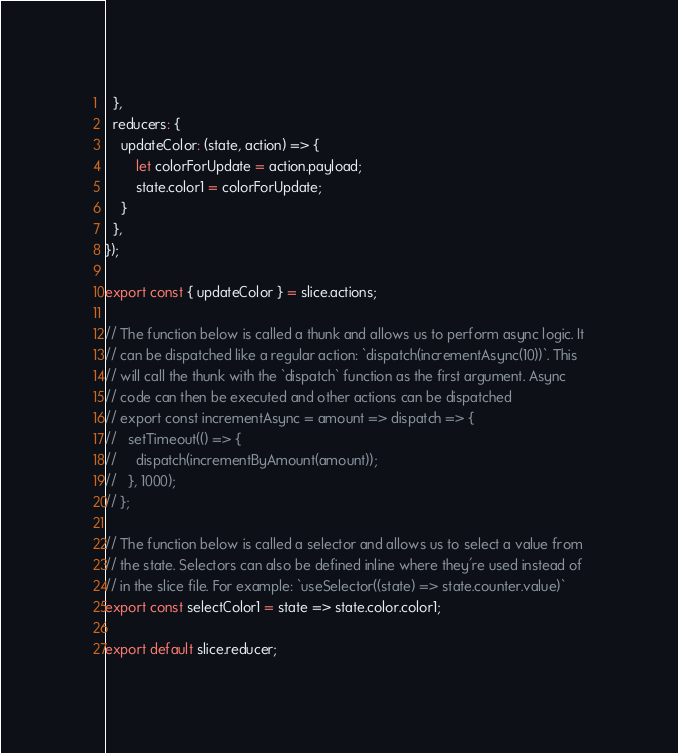Convert code to text. <code><loc_0><loc_0><loc_500><loc_500><_JavaScript_>  },
  reducers: {
    updateColor: (state, action) => {
        let colorForUpdate = action.payload;
        state.color1 = colorForUpdate;
    }
  },
});

export const { updateColor } = slice.actions;

// The function below is called a thunk and allows us to perform async logic. It
// can be dispatched like a regular action: `dispatch(incrementAsync(10))`. This
// will call the thunk with the `dispatch` function as the first argument. Async
// code can then be executed and other actions can be dispatched
// export const incrementAsync = amount => dispatch => {
//   setTimeout(() => {
//     dispatch(incrementByAmount(amount));
//   }, 1000);
// };

// The function below is called a selector and allows us to select a value from
// the state. Selectors can also be defined inline where they're used instead of
// in the slice file. For example: `useSelector((state) => state.counter.value)`
export const selectColor1 = state => state.color.color1;

export default slice.reducer;
</code> 